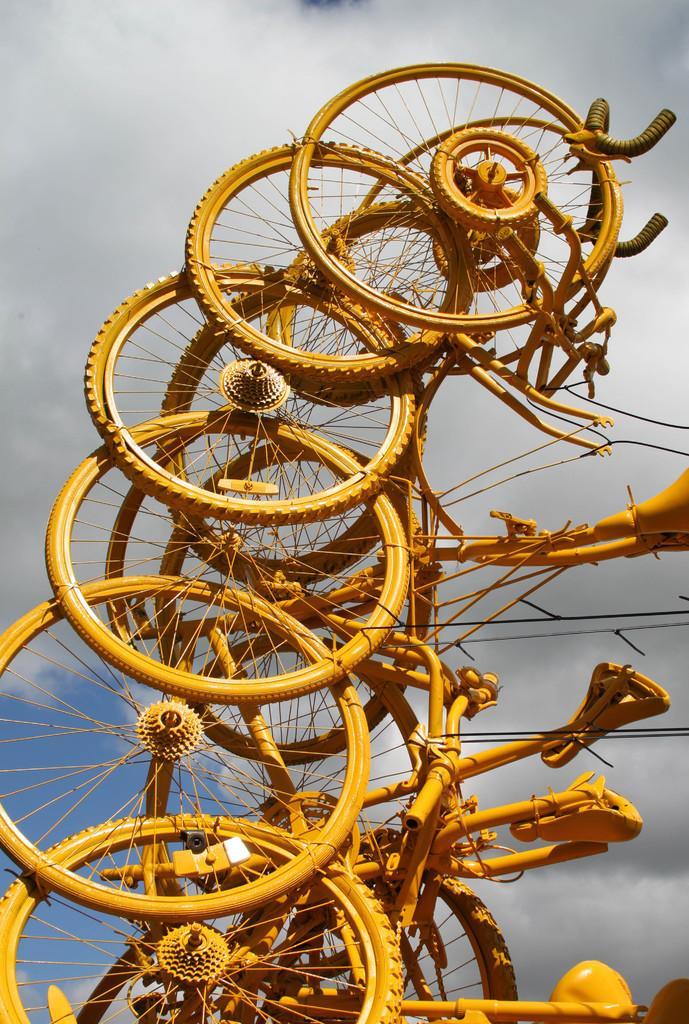Could you give a brief overview of what you see in this image? In this image we can see many bicycles. We can see the clouds in the sky. 